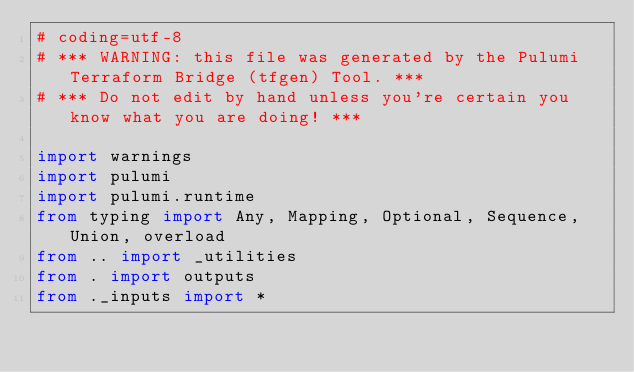<code> <loc_0><loc_0><loc_500><loc_500><_Python_># coding=utf-8
# *** WARNING: this file was generated by the Pulumi Terraform Bridge (tfgen) Tool. ***
# *** Do not edit by hand unless you're certain you know what you are doing! ***

import warnings
import pulumi
import pulumi.runtime
from typing import Any, Mapping, Optional, Sequence, Union, overload
from .. import _utilities
from . import outputs
from ._inputs import *
</code> 